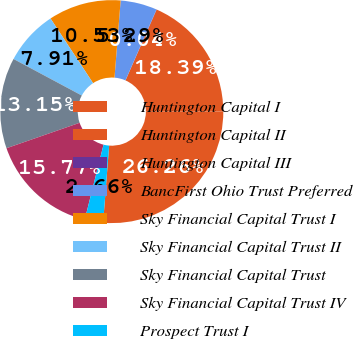Convert chart to OTSL. <chart><loc_0><loc_0><loc_500><loc_500><pie_chart><fcel>Huntington Capital I<fcel>Huntington Capital II<fcel>Huntington Capital III<fcel>BancFirst Ohio Trust Preferred<fcel>Sky Financial Capital Trust I<fcel>Sky Financial Capital Trust II<fcel>Sky Financial Capital Trust<fcel>Sky Financial Capital Trust IV<fcel>Prospect Trust I<nl><fcel>26.26%<fcel>18.39%<fcel>0.04%<fcel>5.29%<fcel>10.53%<fcel>7.91%<fcel>13.15%<fcel>15.77%<fcel>2.66%<nl></chart> 